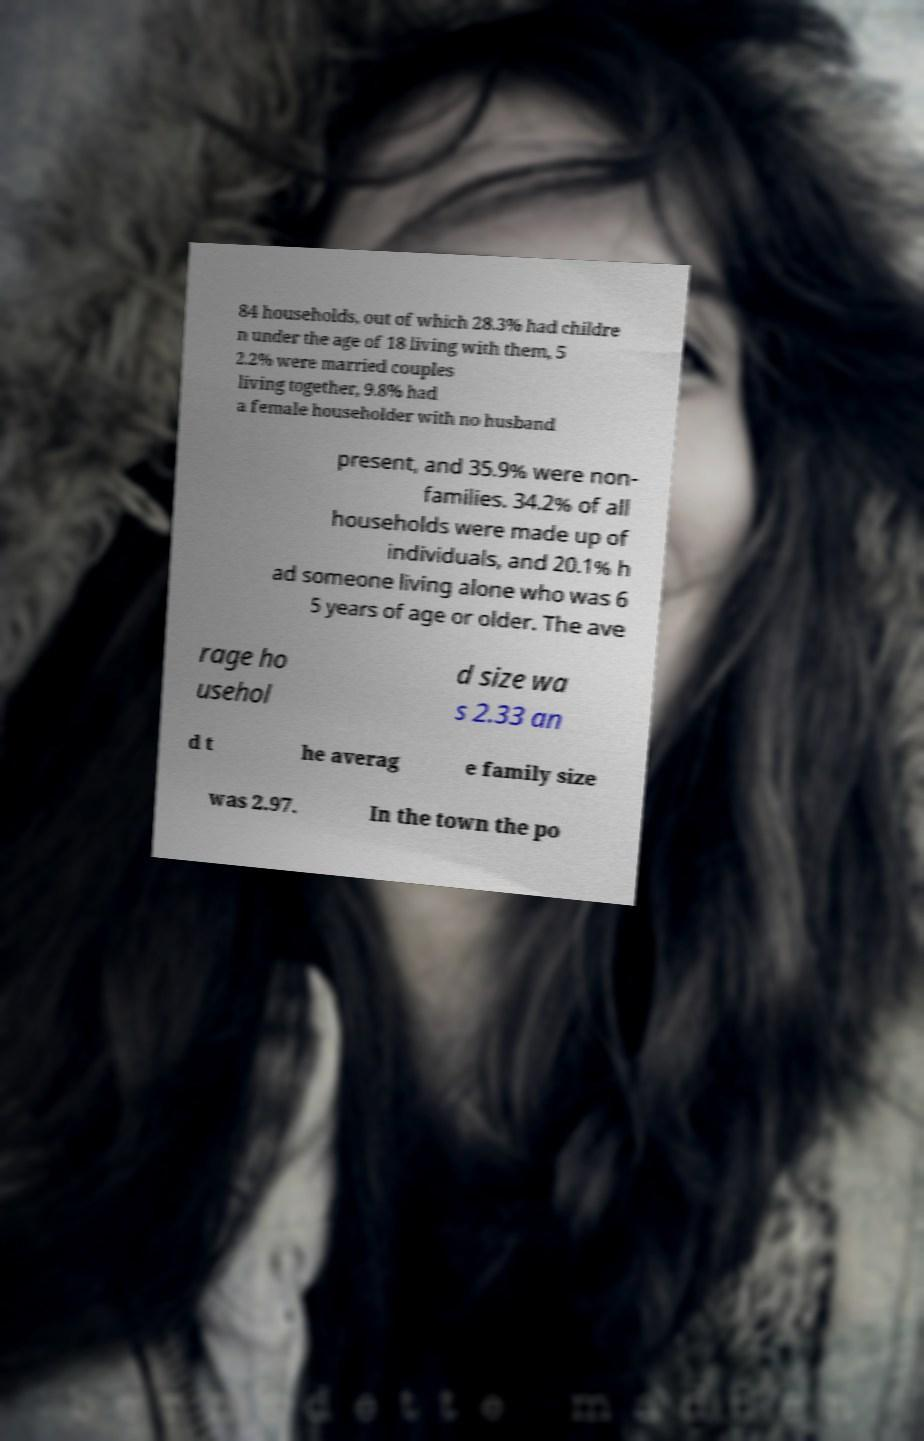I need the written content from this picture converted into text. Can you do that? 84 households, out of which 28.3% had childre n under the age of 18 living with them, 5 2.2% were married couples living together, 9.8% had a female householder with no husband present, and 35.9% were non- families. 34.2% of all households were made up of individuals, and 20.1% h ad someone living alone who was 6 5 years of age or older. The ave rage ho usehol d size wa s 2.33 an d t he averag e family size was 2.97. In the town the po 